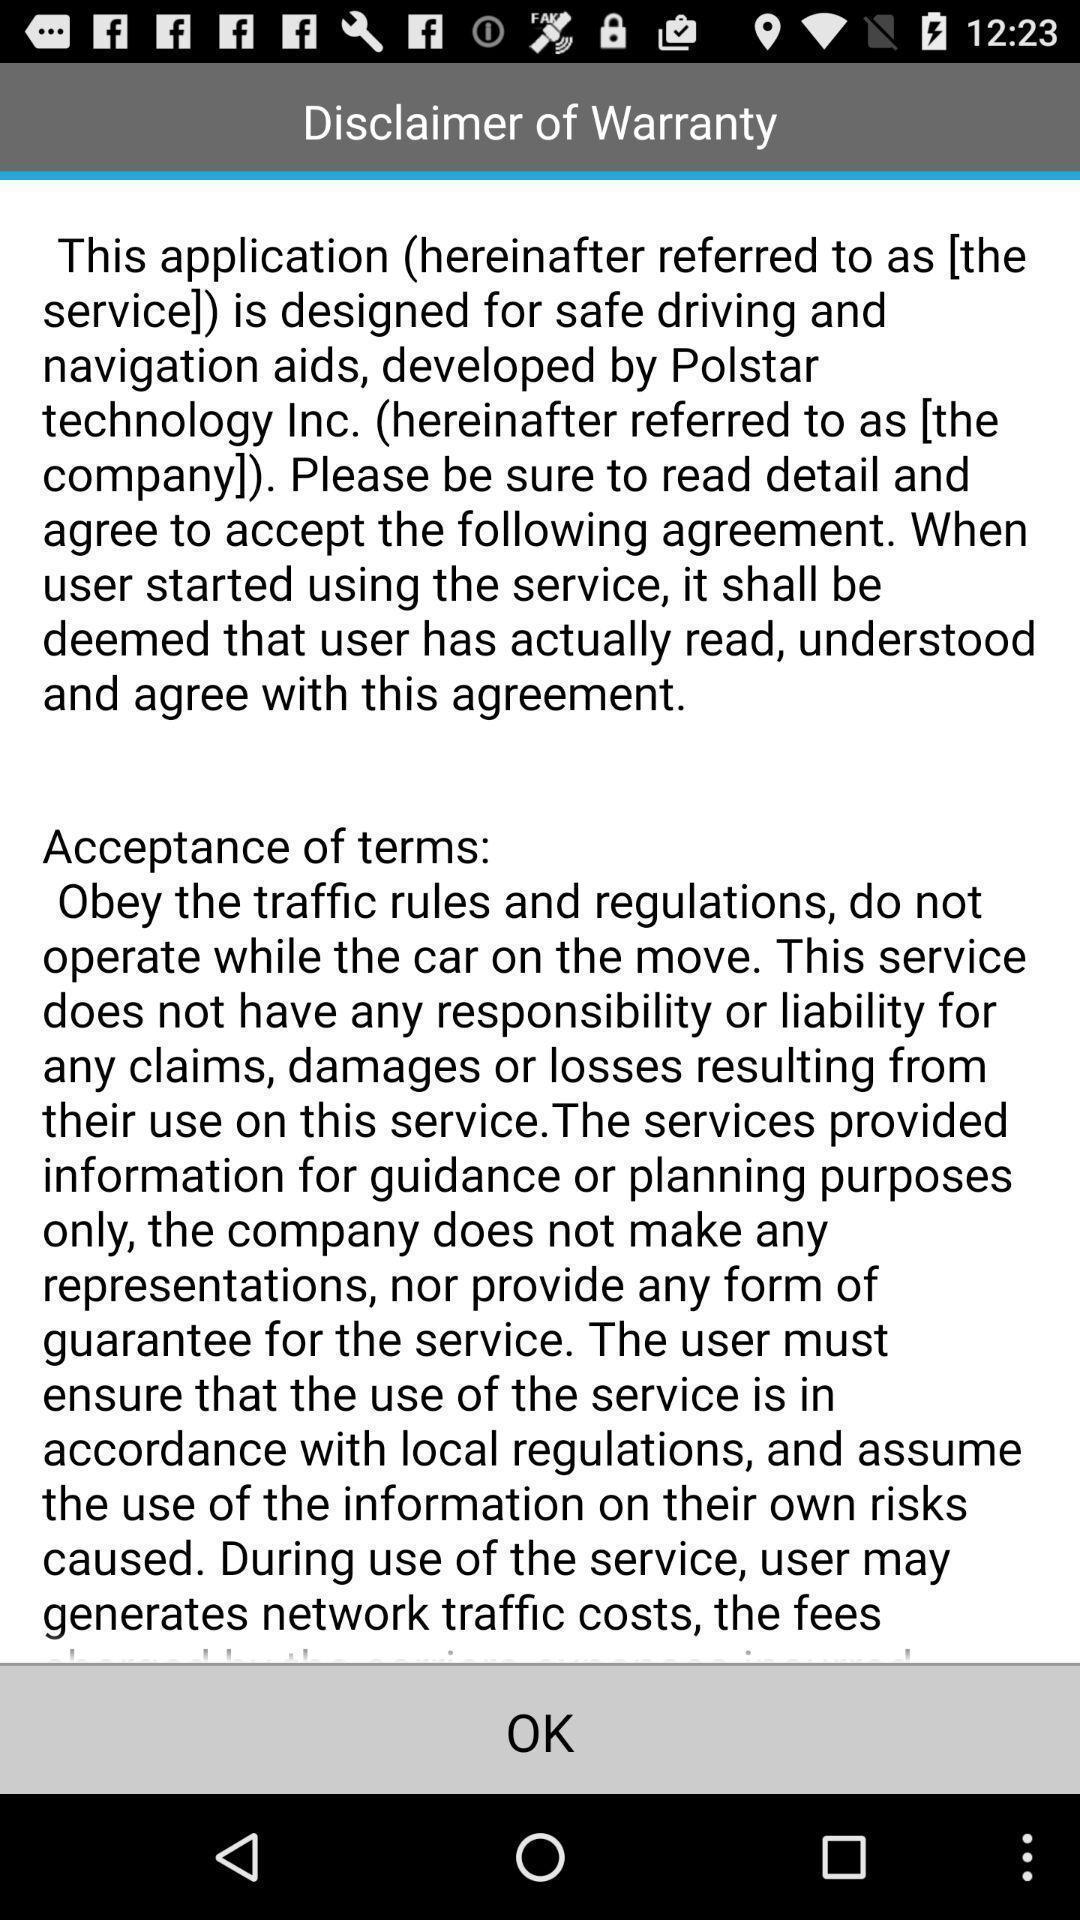Provide a description of this screenshot. Page displaying with information about application disclaimer. 